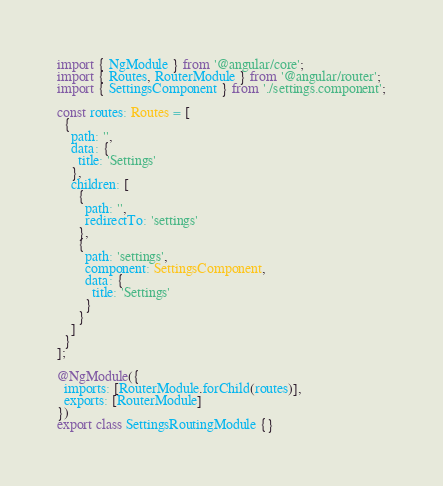<code> <loc_0><loc_0><loc_500><loc_500><_TypeScript_>import { NgModule } from '@angular/core';
import { Routes, RouterModule } from '@angular/router';
import { SettingsComponent } from './settings.component';

const routes: Routes = [
  {
    path: '',
    data: {
      title: 'Settings'
    },
    children: [
      {
        path: '',
        redirectTo: 'settings'
      },
      {
        path: 'settings',
        component: SettingsComponent,
        data: {
          title: 'Settings'
        }
      }
    ]
  }
];

@NgModule({
  imports: [RouterModule.forChild(routes)],
  exports: [RouterModule]
})
export class SettingsRoutingModule {}
</code> 